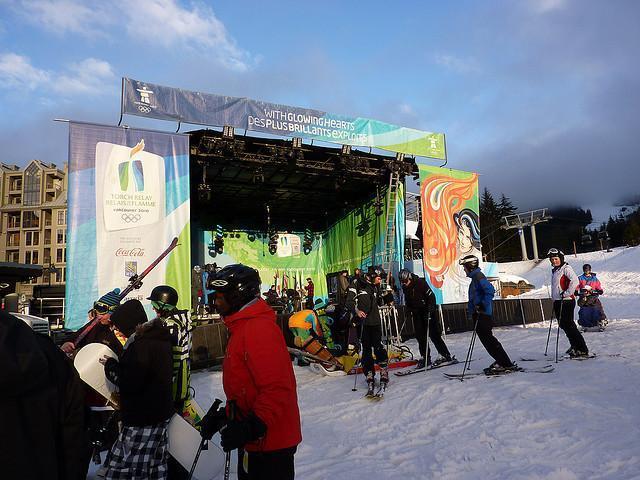How many people are in the picture?
Give a very brief answer. 9. How many people are between the two orange buses in the image?
Give a very brief answer. 0. 